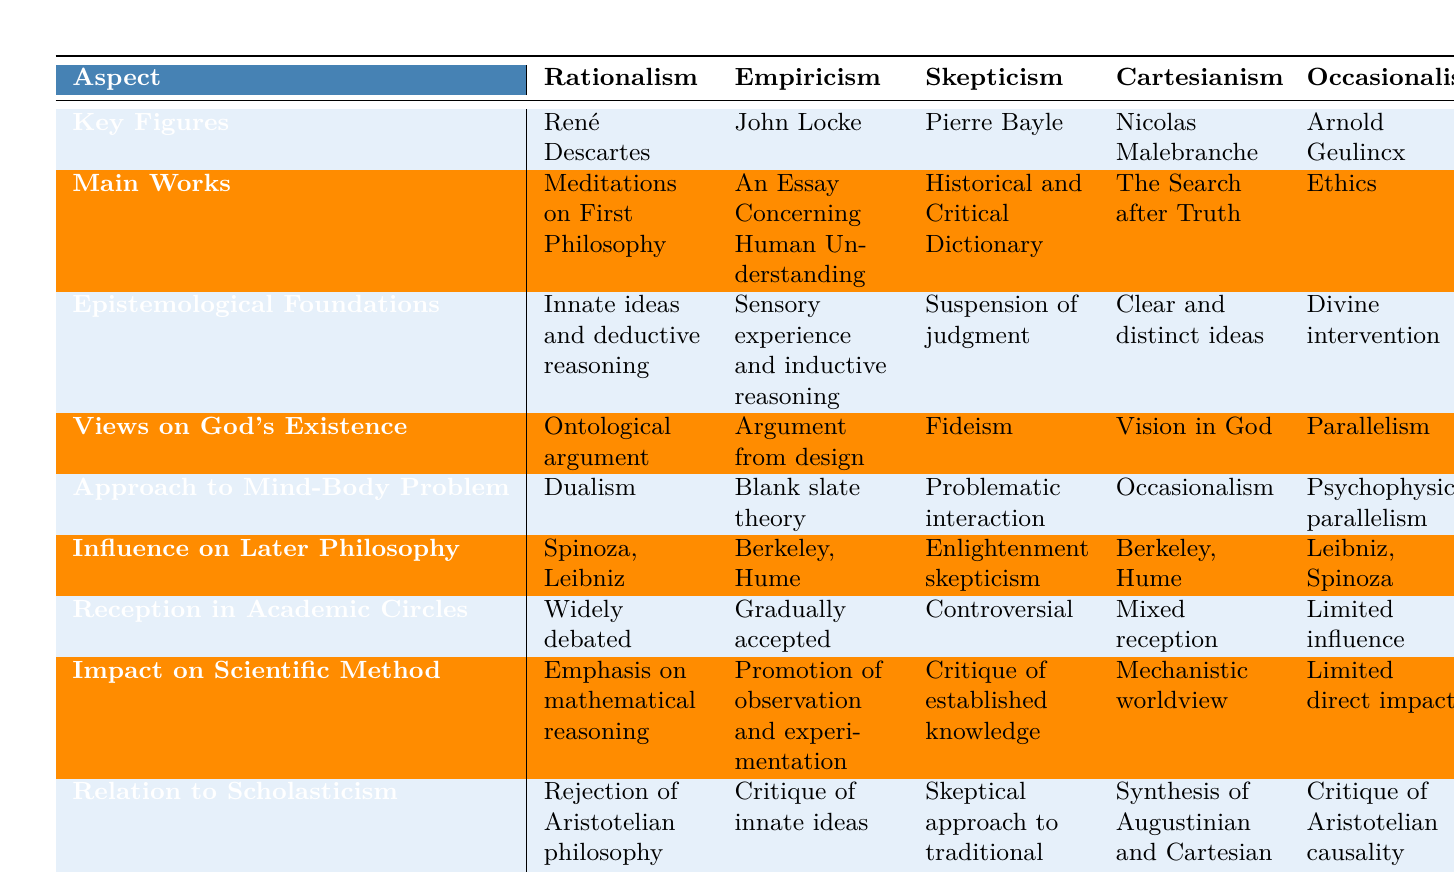What key figure is associated with Empiricism? The table lists John Locke under the key figures for Empiricism, as it is specified in the "Key Figures" row corresponding to the Empiricism column.
Answer: John Locke Which philosophical school discusses the "ontological argument" regarding God's existence? The table indicates that Rationalism's view on God's existence includes the "ontological argument," as noted in the corresponding row and column for Rationalism.
Answer: Rationalism What is the main work of the philosopher associated with Cartesianism? The main work listed for Cartesianism is "The Search after Truth," which is found in the "Main Works" row for the Cartesianism column.
Answer: The Search after Truth Is Skepticism generally accepted in academic circles? According to the table, Skepticism has a "Controversial" reception in academic circles, which indicates that it is not generally accepted.
Answer: No Which philosophical school has the most influence on later philosophy? Both Rationalism and Cartesianism influence later thinkers like Spinoza and Hume but are noted only once under the Influence on Later Philosophy. Hence, it can be relatively assessed as Rationalism having notable influence on figures like Spinoza and Leibniz.
Answer: Rationalism What is the reception of Occasionalism in academic circles? The reception of Occasionalism in academic circles as per the table is noted as "Limited influence," which is stated explicitly in the corresponding row.
Answer: Limited influence Which philosophical school emphasizes inductive reasoning? The table specifies that Empiricism emphasizes sensory experience and inductive reasoning, clearly showing this in the associated row and column for Empiricism.
Answer: Empiricism Compare the views on God's existence between Rationalism and Occasionalism. Rationalism holds the ontological argument for God's existence, while Occasionalism adopts the notion of Parallelism regarding God's relation to events, as seen in the Views on God's Existence row.
Answer: Rationalism: Ontological argument, Occasionalism: Parallelism How many philosophical schools incorporate ideas related to dualism? The table indicates that Rationalism and Cartesianism both approach the mind-body problem with dualism, found in the respective rows under the Approach to Mind-Body Problem section. Therefore, two schools incorporate dualism.
Answer: 2 What does the "Critique of established knowledge" pertain to regarding the impact on scientific method? The table states that Skepticism critiques established knowledge, as noted in the "Impact on Scientific Method" row; therefore, it can reason that this is a significant approach of Skepticism.
Answer: Skepticism 